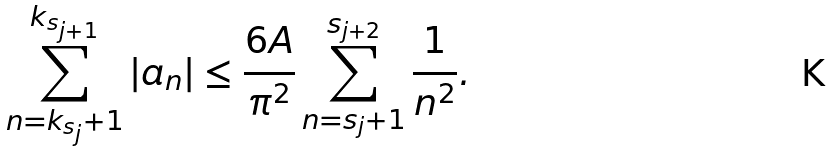Convert formula to latex. <formula><loc_0><loc_0><loc_500><loc_500>\sum _ { n = k _ { s _ { j } } + 1 } ^ { k _ { s _ { j + 1 } } } | a _ { n } | \leq \frac { 6 A } { \pi ^ { 2 } } \sum _ { n = s _ { j } + 1 } ^ { s _ { j + 2 } } \frac { 1 } { n ^ { 2 } } .</formula> 